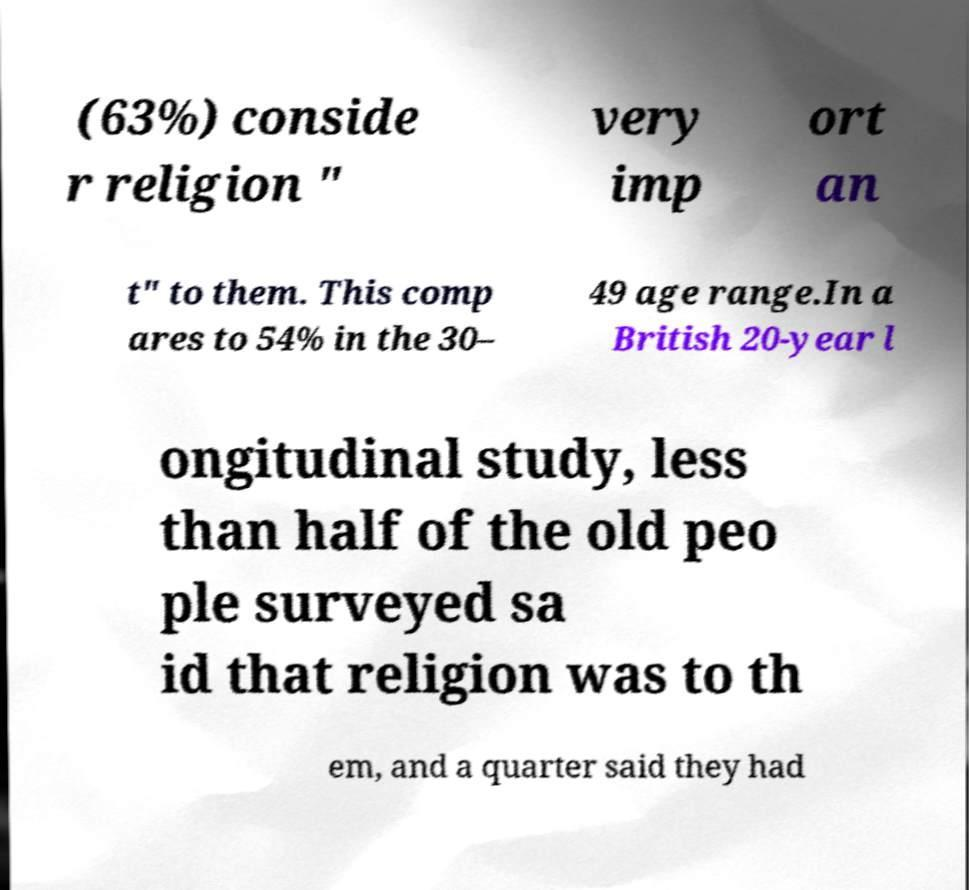Could you assist in decoding the text presented in this image and type it out clearly? (63%) conside r religion " very imp ort an t" to them. This comp ares to 54% in the 30– 49 age range.In a British 20-year l ongitudinal study, less than half of the old peo ple surveyed sa id that religion was to th em, and a quarter said they had 